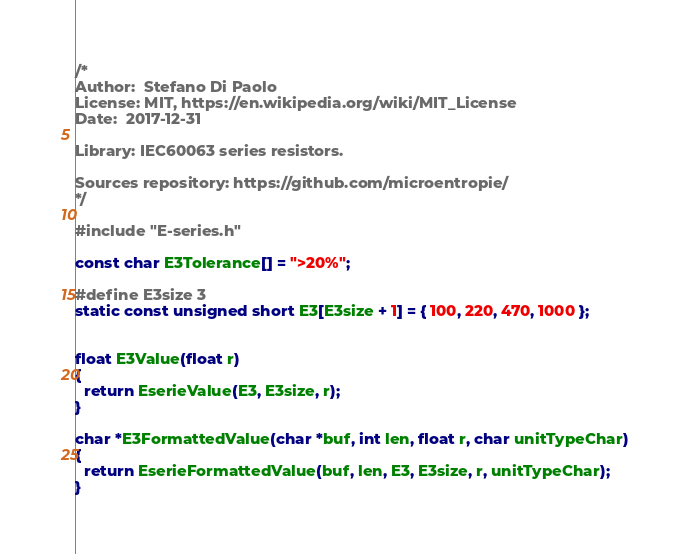Convert code to text. <code><loc_0><loc_0><loc_500><loc_500><_C++_>/*
Author:  Stefano Di Paolo
License: MIT, https://en.wikipedia.org/wiki/MIT_License
Date:  2017-12-31

Library: IEC60063 series resistors.

Sources repository: https://github.com/microentropie/
*/

#include "E-series.h"

const char E3Tolerance[] = ">20%";

#define E3size 3
static const unsigned short E3[E3size + 1] = { 100, 220, 470, 1000 };


float E3Value(float r)
{
  return EserieValue(E3, E3size, r);
}

char *E3FormattedValue(char *buf, int len, float r, char unitTypeChar)
{
  return EserieFormattedValue(buf, len, E3, E3size, r, unitTypeChar);
}
</code> 